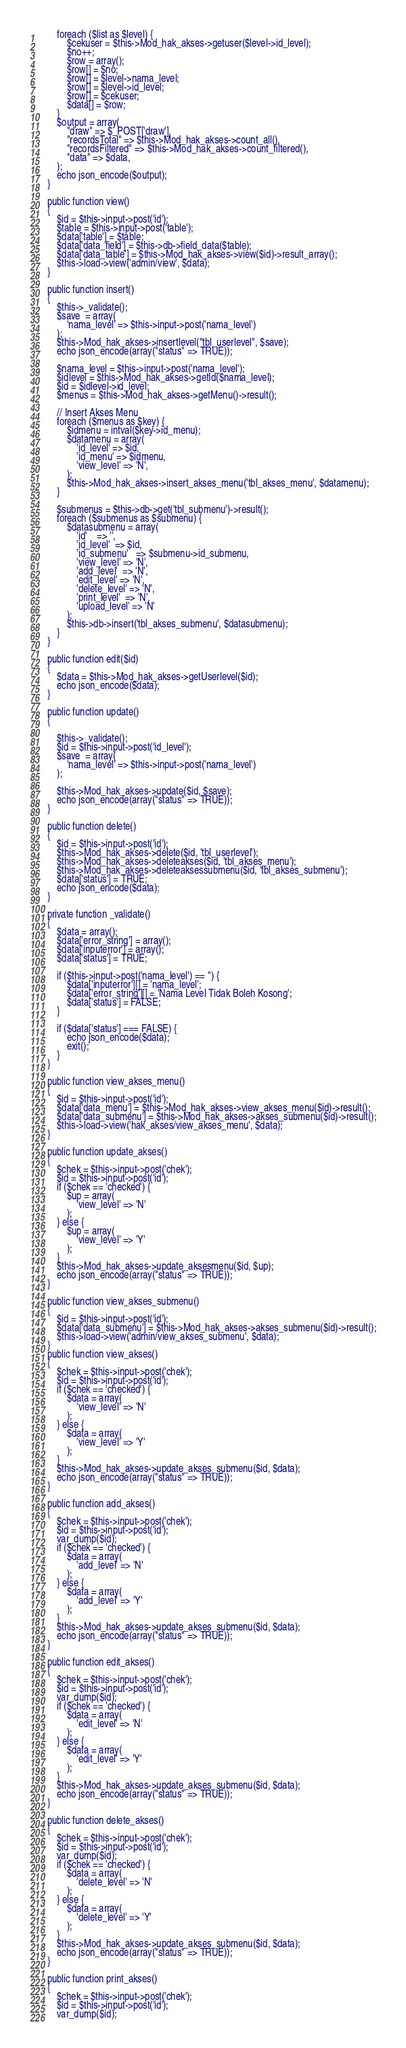Convert code to text. <code><loc_0><loc_0><loc_500><loc_500><_PHP_>        foreach ($list as $level) {
            $cekuser = $this->Mod_hak_akses->getuser($level->id_level);
            $no++;
            $row = array();
            $row[] = $no;
            $row[] = $level->nama_level;
            $row[] = $level->id_level;
            $row[] = $cekuser;
            $data[] = $row;
        }
        $output = array(
            "draw" => $_POST['draw'],
            "recordsTotal" => $this->Mod_hak_akses->count_all(),
            "recordsFiltered" => $this->Mod_hak_akses->count_filtered(),
            "data" => $data,
        );
        echo json_encode($output);
    }

    public function view()
    {
        $id = $this->input->post('id');
        $table = $this->input->post('table');
        $data['table'] = $table;
        $data['data_field'] = $this->db->field_data($table);
        $data['data_table'] = $this->Mod_hak_akses->view($id)->result_array();
        $this->load->view('admin/view', $data);
    }

    public function insert()
    {
        $this->_validate();
        $save  = array(
            'nama_level' => $this->input->post('nama_level')
        );
        $this->Mod_hak_akses->insertlevel("tbl_userlevel", $save);
        echo json_encode(array("status" => TRUE));

        $nama_level = $this->input->post('nama_level');
        $idlevel = $this->Mod_hak_akses->getId($nama_level);
        $id = $idlevel->id_level;
        $menus = $this->Mod_hak_akses->getMenu()->result();

        // Insert Akses Menu
        foreach ($menus as $key) {
            $idmenu = intval($key->id_menu);
            $datamenu = array(
                'id_level' => $id,
                'id_menu' => $idmenu,
                'view_level' => 'N',
            );
            $this->Mod_hak_akses->insert_akses_menu('tbl_akses_menu', $datamenu);
        }

        $submenus = $this->db->get('tbl_submenu')->result();
        foreach ($submenus as $submenu) {
            $datasubmenu = array(
                'id'    => '',
                'id_level'  => $id,
                'id_submenu'   => $submenu->id_submenu,
                'view_level' => 'N',
                'add_level'  => 'N',
                'edit_level' => 'N',
                'delete_level' => 'N',
                'print_level'  => 'N',
                'upload_level' => 'N'
            );
            $this->db->insert('tbl_akses_submenu', $datasubmenu);
        }
    }

    public function edit($id)
    {
        $data = $this->Mod_hak_akses->getUserlevel($id);
        echo json_encode($data);
    }

    public function update()
    {

        $this->_validate();
        $id = $this->input->post('id_level');
        $save  = array(
            'nama_level' => $this->input->post('nama_level')
        );

        $this->Mod_hak_akses->update($id, $save);
        echo json_encode(array("status" => TRUE));
    }

    public function delete()
    {
        $id = $this->input->post('id');
        $this->Mod_hak_akses->delete($id, 'tbl_userlevel');
        $this->Mod_hak_akses->deleteakses($id, 'tbl_akses_menu');
        $this->Mod_hak_akses->deleteaksessubmenu($id, 'tbl_akses_submenu');
        $data['status'] = TRUE;
        echo json_encode($data);
    }

    private function _validate()
    {
        $data = array();
        $data['error_string'] = array();
        $data['inputerror'] = array();
        $data['status'] = TRUE;

        if ($this->input->post('nama_level') == '') {
            $data['inputerror'][] = 'nama_level';
            $data['error_string'][] = 'Nama Level Tidak Boleh Kosong';
            $data['status'] = FALSE;
        }

        if ($data['status'] === FALSE) {
            echo json_encode($data);
            exit();
        }
    }

    public function view_akses_menu()
    {
        $id = $this->input->post('id');
        $data['data_menu'] = $this->Mod_hak_akses->view_akses_menu($id)->result();
        $data['data_submenu'] = $this->Mod_hak_akses->akses_submenu($id)->result();
        $this->load->view('hak_akses/view_akses_menu', $data);
    }

    public function update_akses()
    {
        $chek = $this->input->post('chek');
        $id = $this->input->post('id');
        if ($chek == 'checked') {
            $up = array(
                'view_level' => 'N'
            );
        } else {
            $up = array(
                'view_level' => 'Y'
            );
        }
        $this->Mod_hak_akses->update_aksesmenu($id, $up);
        echo json_encode(array("status" => TRUE));
    }

    public function view_akses_submenu()
    {
        $id = $this->input->post('id');
        $data['data_submenu'] = $this->Mod_hak_akses->akses_submenu($id)->result();
        $this->load->view('admin/view_akses_submenu', $data);
    }
    public function view_akses()
    {
        $chek = $this->input->post('chek');
        $id = $this->input->post('id');
        if ($chek == 'checked') {
            $data = array(
                'view_level' => 'N'
            );
        } else {
            $data = array(
                'view_level' => 'Y'
            );
        }
        $this->Mod_hak_akses->update_akses_submenu($id, $data);
        echo json_encode(array("status" => TRUE));
    }

    public function add_akses()
    {
        $chek = $this->input->post('chek');
        $id = $this->input->post('id');
        var_dump($id);
        if ($chek == 'checked') {
            $data = array(
                'add_level' => 'N'
            );
        } else {
            $data = array(
                'add_level' => 'Y'
            );
        }
        $this->Mod_hak_akses->update_akses_submenu($id, $data);
        echo json_encode(array("status" => TRUE));
    }

    public function edit_akses()
    {
        $chek = $this->input->post('chek');
        $id = $this->input->post('id');
        var_dump($id);
        if ($chek == 'checked') {
            $data = array(
                'edit_level' => 'N'
            );
        } else {
            $data = array(
                'edit_level' => 'Y'
            );
        }
        $this->Mod_hak_akses->update_akses_submenu($id, $data);
        echo json_encode(array("status" => TRUE));
    }

    public function delete_akses()
    {
        $chek = $this->input->post('chek');
        $id = $this->input->post('id');
        var_dump($id);
        if ($chek == 'checked') {
            $data = array(
                'delete_level' => 'N'
            );
        } else {
            $data = array(
                'delete_level' => 'Y'
            );
        }
        $this->Mod_hak_akses->update_akses_submenu($id, $data);
        echo json_encode(array("status" => TRUE));
    }

    public function print_akses()
    {
        $chek = $this->input->post('chek');
        $id = $this->input->post('id');
        var_dump($id);</code> 